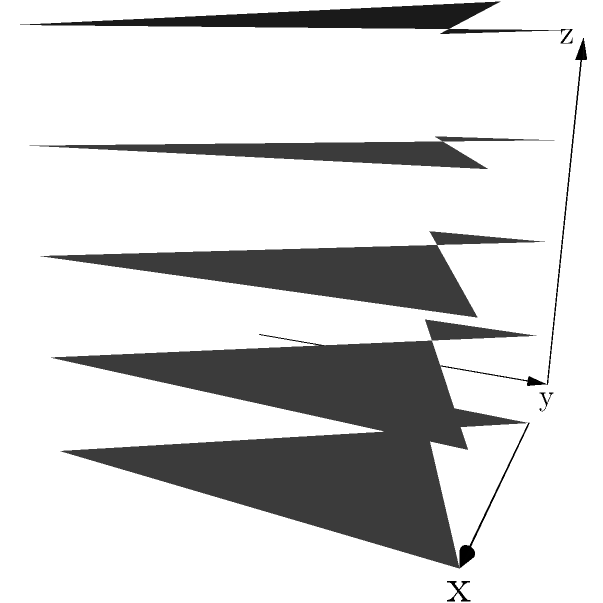Consider the negative space formed between stacked vinyl records, as shown in the diagram. If we model this space topologically, what are the homology groups $H_0$, $H_1$, and $H_2$ of this space? Express your answer in terms of the number of records $n$ and use $\mathbb{Z}$ to denote the integers. Let's approach this step-by-step:

1) First, let's visualize the space. The negative space between stacked records forms a cylindrical shape with two open ends.

2) $H_0$ represents the number of connected components. In this case, we have one connected space, so:
   $H_0 \cong \mathbb{Z}$

3) $H_1$ represents the number of 1-dimensional holes (loops). In our space:
   - We have one loop around the center spindle.
   - We also have $(n-1)$ loops between adjacent records.
   So, $H_1 \cong \mathbb{Z}^n$ (n copies of $\mathbb{Z}$)

4) $H_2$ represents the number of 2-dimensional holes (voids). Our space is open at both ends, so it doesn't enclose a void. Therefore:
   $H_2 \cong 0$

5) Higher dimensional homology groups ($H_3$ and above) are all trivial (0) because our space is essentially 2-dimensional.
Answer: $H_0 \cong \mathbb{Z}$, $H_1 \cong \mathbb{Z}^n$, $H_2 \cong 0$ 